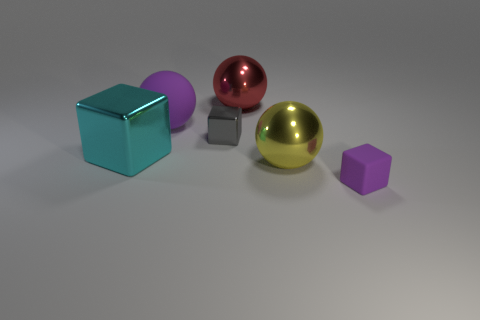Is the number of tiny things that are behind the large matte thing less than the number of large cyan metallic things that are behind the big yellow metallic sphere?
Your response must be concise. Yes. What is the shape of the rubber thing that is behind the rubber object that is to the right of the gray thing?
Offer a terse response. Sphere. Are there any other things of the same color as the tiny metal object?
Ensure brevity in your answer.  No. Is the large matte sphere the same color as the small matte thing?
Provide a short and direct response. Yes. How many green objects are matte things or blocks?
Keep it short and to the point. 0. Are there fewer gray metal blocks behind the gray metallic thing than small shiny objects?
Make the answer very short. Yes. There is a tiny object that is on the left side of the yellow ball; what number of gray things are left of it?
Provide a short and direct response. 0. What number of other objects are there of the same size as the yellow metallic object?
Give a very brief answer. 3. How many objects are either tiny blue metal blocks or cubes that are behind the small purple matte block?
Ensure brevity in your answer.  2. Are there fewer small things than purple spheres?
Make the answer very short. No. 